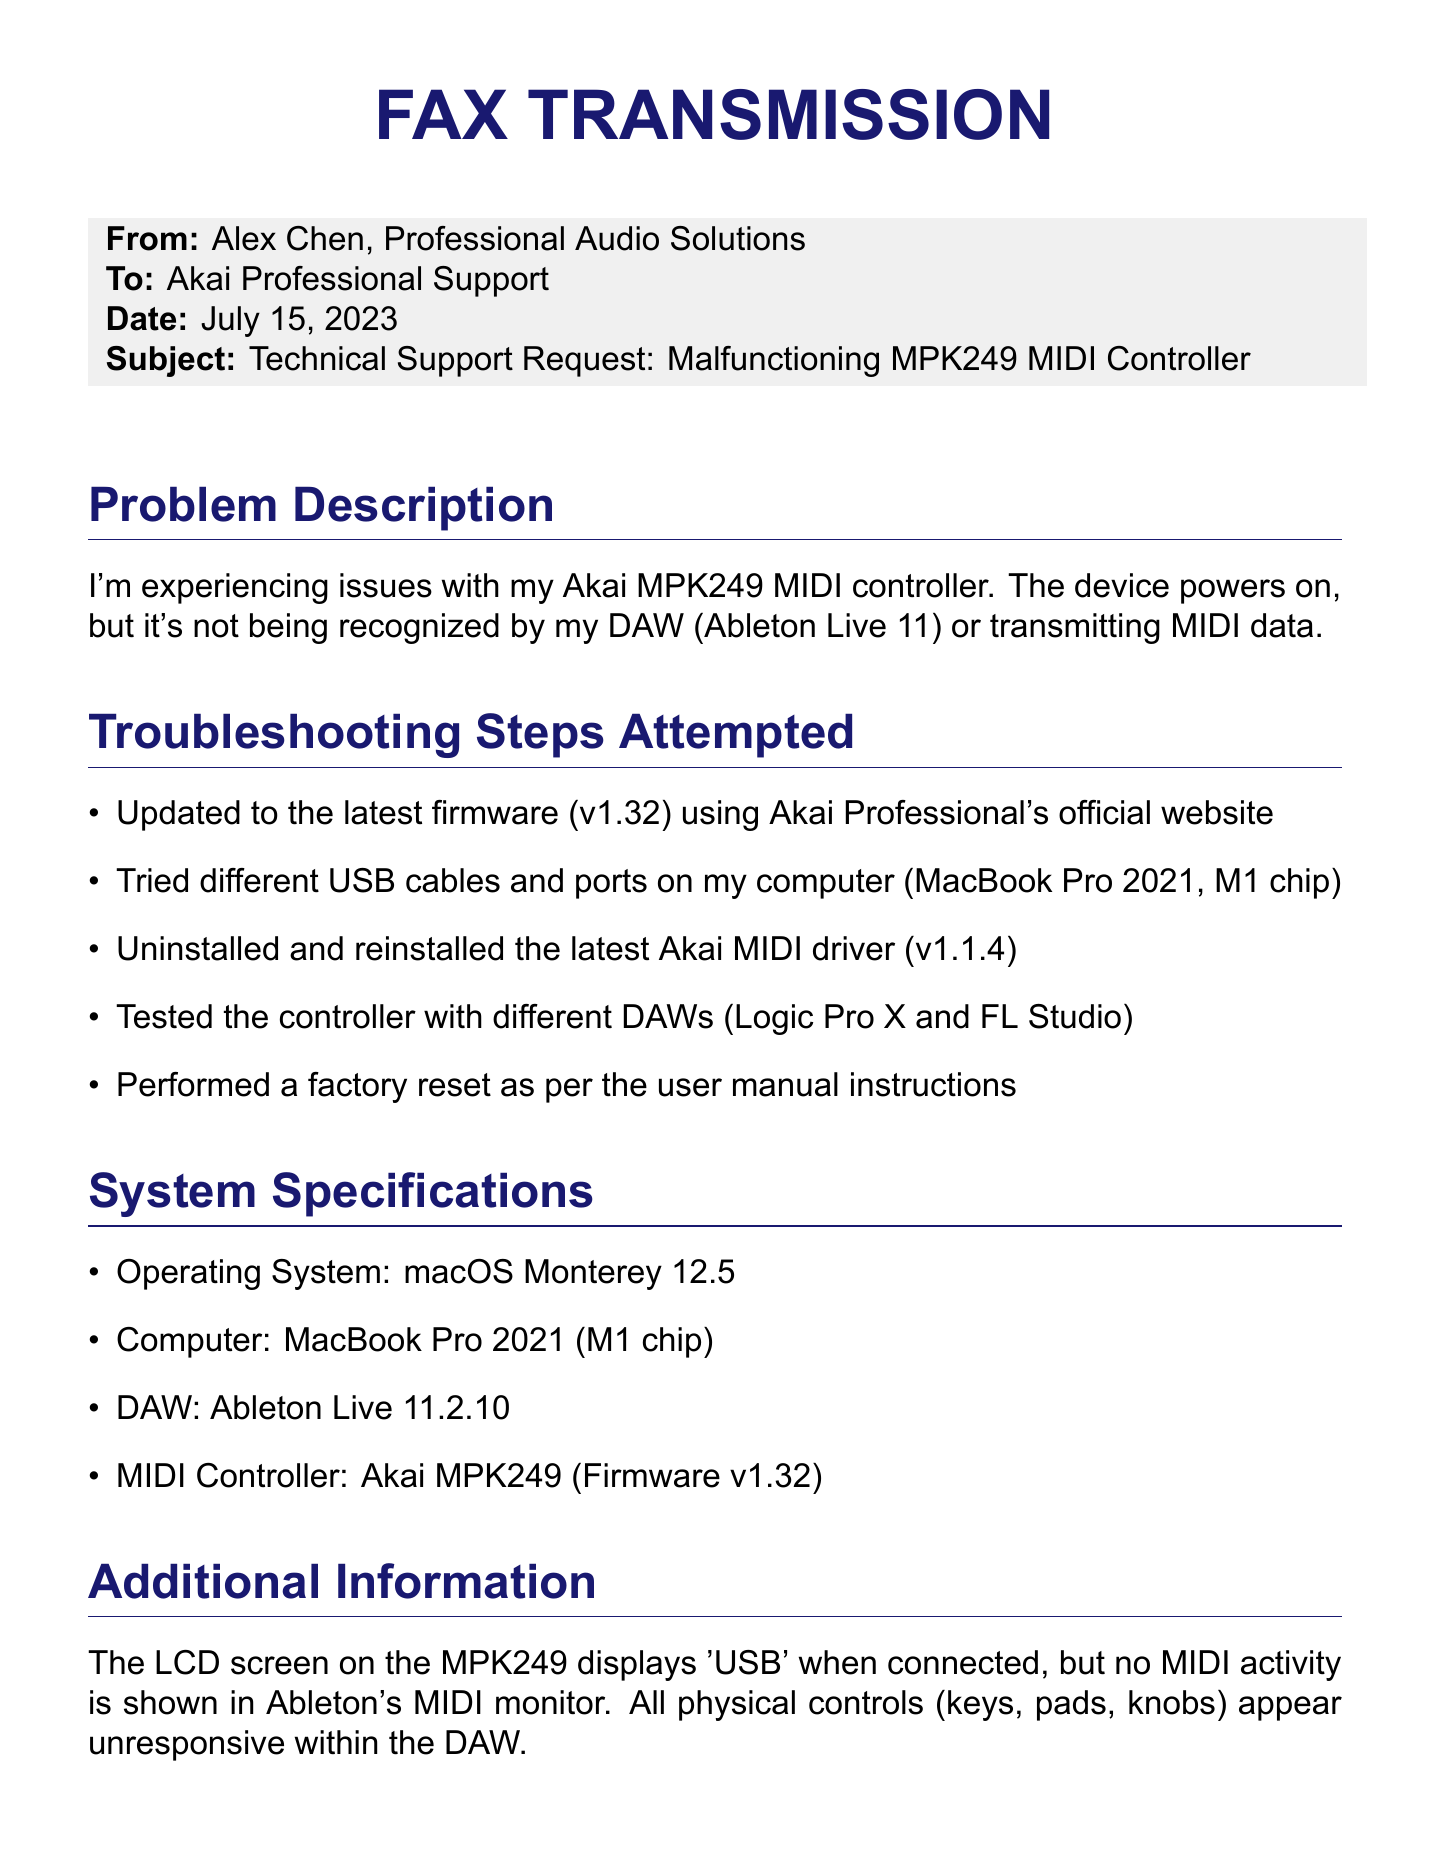What is the date of the fax? The date is listed in the document under the details section, indicating when the fax was sent.
Answer: July 15, 2023 Who is the sender of the fax? The sender's name is provided at the beginning of the fax in the "From" section.
Answer: Alex Chen What firmware version is the MIDI controller running? The firmware version is mentioned in both the problem description and system specifications sections.
Answer: v1.32 What operating system is being used? The operating system details are specified in the system specifications section.
Answer: macOS Monterey 12.5 How many different DAWs were tested with the MIDI controller? The document mentions testing the controller with multiple DAWs in the troubleshooting steps.
Answer: Three What issue is the MIDI controller experiencing? The problem is discussed in the problem description section of the document.
Answer: Not being recognized What additional troubleshooting step was performed? The attempts made to resolve the problem are listed in the troubleshooting section.
Answer: Factory reset What is the model of the MIDI controller? The model is specified in the system specifications section of the document.
Answer: Akai MPK249 What is the main request in the fax? The request is summarized in the final section, outlining what assistance is needed from support.
Answer: Assistance in resolving the issue 